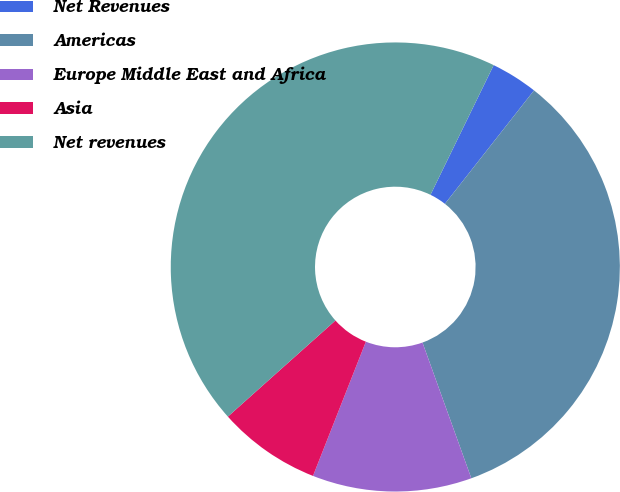<chart> <loc_0><loc_0><loc_500><loc_500><pie_chart><fcel>Net Revenues<fcel>Americas<fcel>Europe Middle East and Africa<fcel>Asia<fcel>Net revenues<nl><fcel>3.38%<fcel>33.91%<fcel>11.47%<fcel>7.42%<fcel>43.83%<nl></chart> 